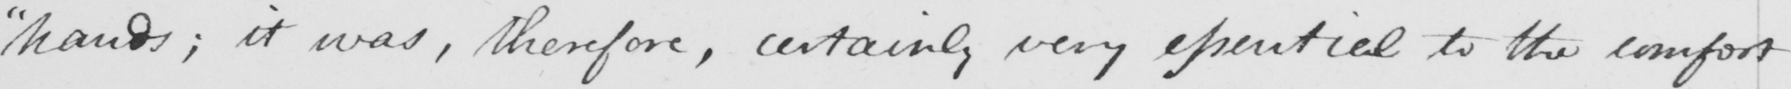Can you read and transcribe this handwriting? " hands ; it was , therefore , certainly very essential to the comfort 